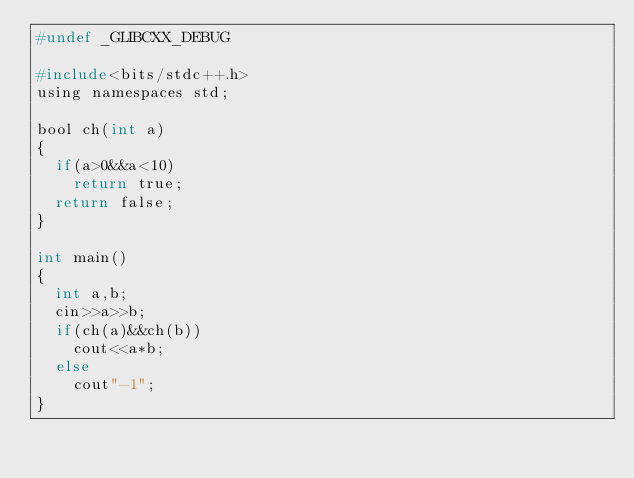<code> <loc_0><loc_0><loc_500><loc_500><_C_>#undef _GLIBCXX_DEBUG

#include<bits/stdc++.h>
using namespaces std;

bool ch(int a)
{
  if(a>0&&a<10)
    return true;
  return false;
}

int main()
{
  int a,b;
  cin>>a>>b;
  if(ch(a)&&ch(b))
    cout<<a*b;
  else
    cout"-1";
}
</code> 